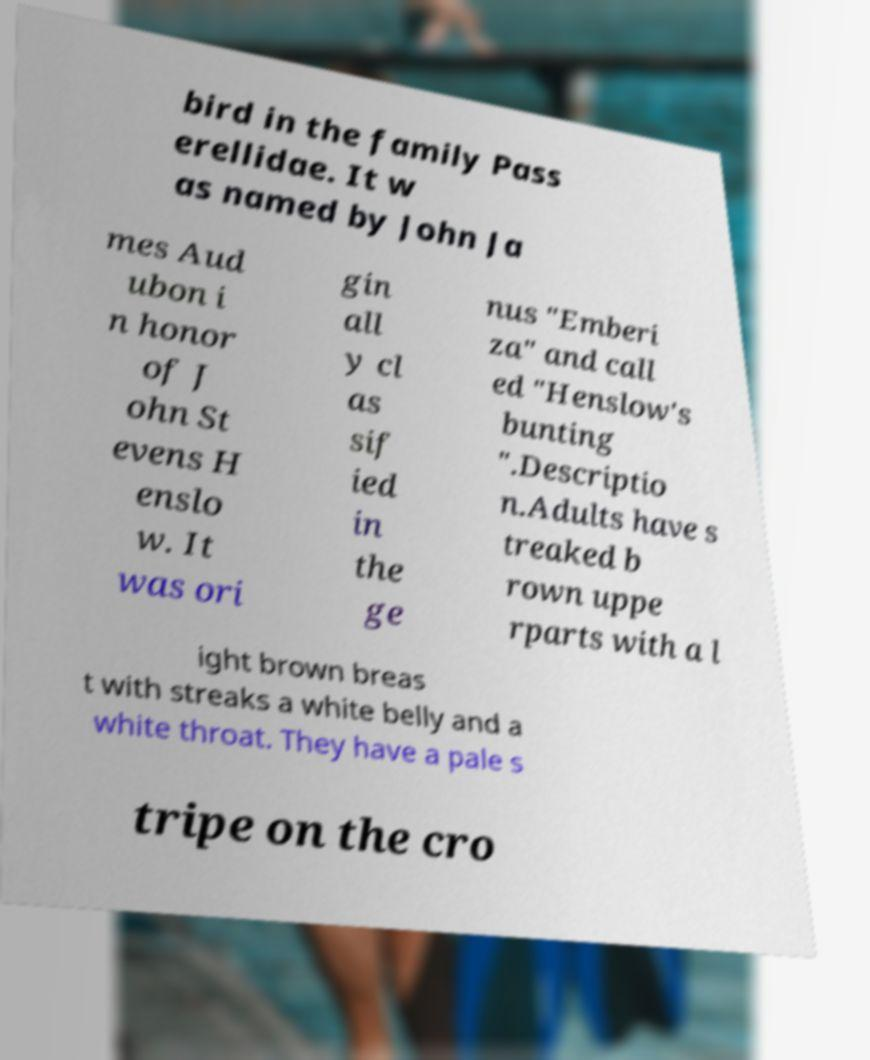Can you read and provide the text displayed in the image?This photo seems to have some interesting text. Can you extract and type it out for me? bird in the family Pass erellidae. It w as named by John Ja mes Aud ubon i n honor of J ohn St evens H enslo w. It was ori gin all y cl as sif ied in the ge nus "Emberi za" and call ed "Henslow's bunting ".Descriptio n.Adults have s treaked b rown uppe rparts with a l ight brown breas t with streaks a white belly and a white throat. They have a pale s tripe on the cro 